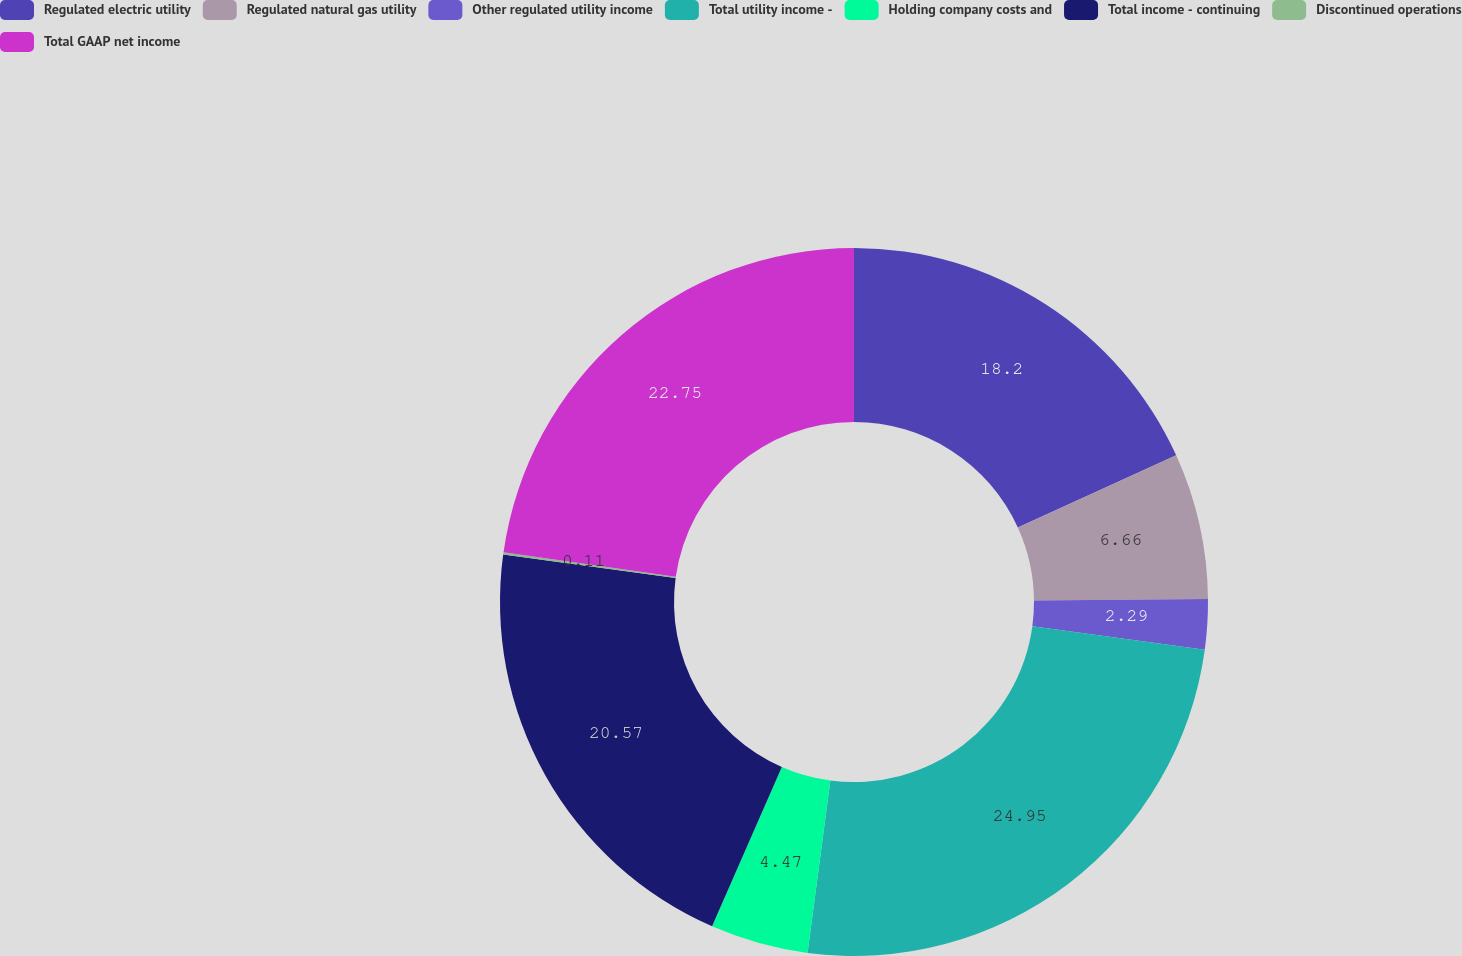Convert chart. <chart><loc_0><loc_0><loc_500><loc_500><pie_chart><fcel>Regulated electric utility<fcel>Regulated natural gas utility<fcel>Other regulated utility income<fcel>Total utility income -<fcel>Holding company costs and<fcel>Total income - continuing<fcel>Discontinued operations<fcel>Total GAAP net income<nl><fcel>18.2%<fcel>6.66%<fcel>2.29%<fcel>24.94%<fcel>4.47%<fcel>20.57%<fcel>0.11%<fcel>22.75%<nl></chart> 